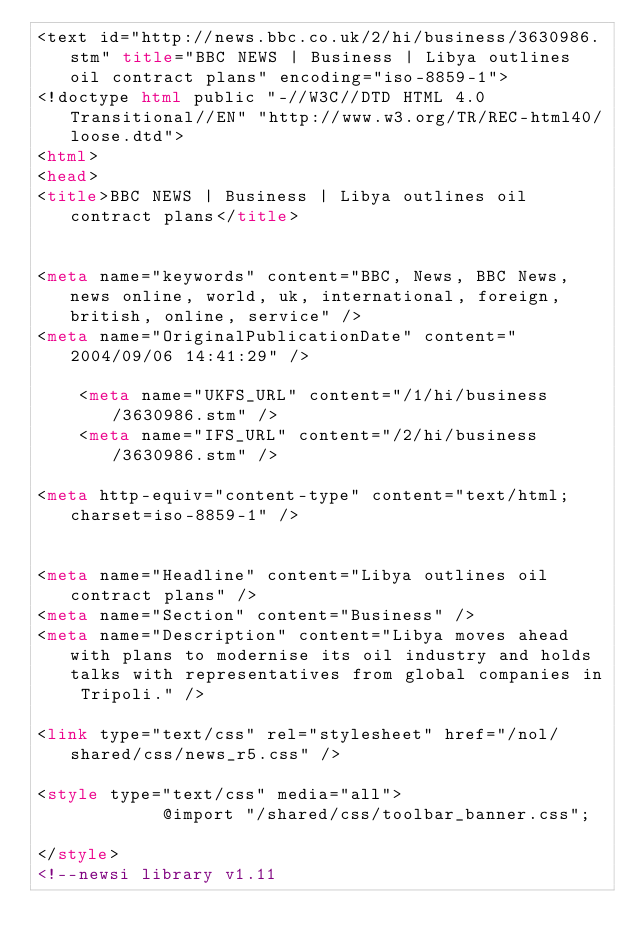Convert code to text. <code><loc_0><loc_0><loc_500><loc_500><_HTML_><text id="http://news.bbc.co.uk/2/hi/business/3630986.stm" title="BBC NEWS | Business | Libya outlines oil contract plans" encoding="iso-8859-1">
<!doctype html public "-//W3C//DTD HTML 4.0 Transitional//EN" "http://www.w3.org/TR/REC-html40/loose.dtd">
<html>
<head>
<title>BBC NEWS | Business | Libya outlines oil contract plans</title>


<meta name="keywords" content="BBC, News, BBC News, news online, world, uk, international, foreign, british, online, service" />
<meta name="OriginalPublicationDate" content="2004/09/06 14:41:29" />

    <meta name="UKFS_URL" content="/1/hi/business/3630986.stm" />
    <meta name="IFS_URL" content="/2/hi/business/3630986.stm" />

<meta http-equiv="content-type" content="text/html;charset=iso-8859-1" />


<meta name="Headline" content="Libya outlines oil contract plans" />
<meta name="Section" content="Business" />
<meta name="Description" content="Libya moves ahead with plans to modernise its oil industry and holds talks with representatives from global companies in Tripoli." />

<link type="text/css" rel="stylesheet" href="/nol/shared/css/news_r5.css" />	

<style type="text/css" media="all">
			@import "/shared/css/toolbar_banner.css";			
</style>
<!--newsi library v1.11</code> 